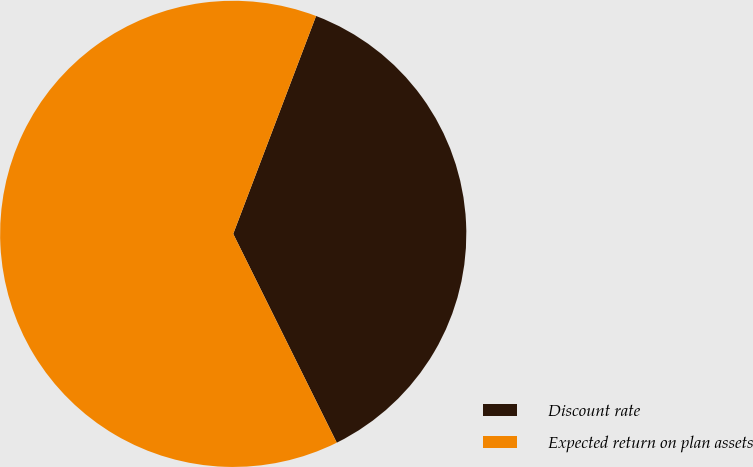<chart> <loc_0><loc_0><loc_500><loc_500><pie_chart><fcel>Discount rate<fcel>Expected return on plan assets<nl><fcel>36.89%<fcel>63.11%<nl></chart> 